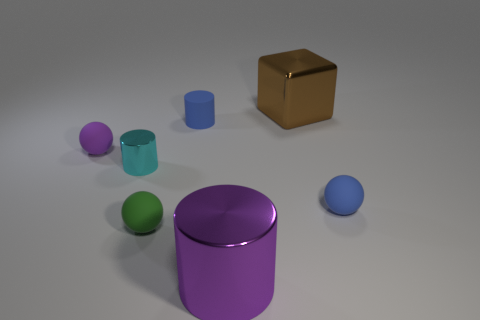What number of purple things are either large metal blocks or small matte spheres?
Keep it short and to the point. 1. Are there any objects of the same color as the tiny rubber cylinder?
Your answer should be very brief. Yes. Is there a small green cylinder that has the same material as the green sphere?
Provide a succinct answer. No. What is the shape of the small matte object that is both in front of the small purple rubber sphere and behind the small green object?
Give a very brief answer. Sphere. What number of small objects are brown metallic spheres or blue spheres?
Ensure brevity in your answer.  1. What material is the small purple thing?
Offer a very short reply. Rubber. How many other objects are the same shape as the brown shiny object?
Provide a short and direct response. 0. How big is the block?
Provide a succinct answer. Large. What is the size of the rubber thing that is in front of the small cyan shiny thing and on the left side of the blue cylinder?
Provide a short and direct response. Small. There is a tiny blue thing behind the blue sphere; what shape is it?
Offer a terse response. Cylinder. 